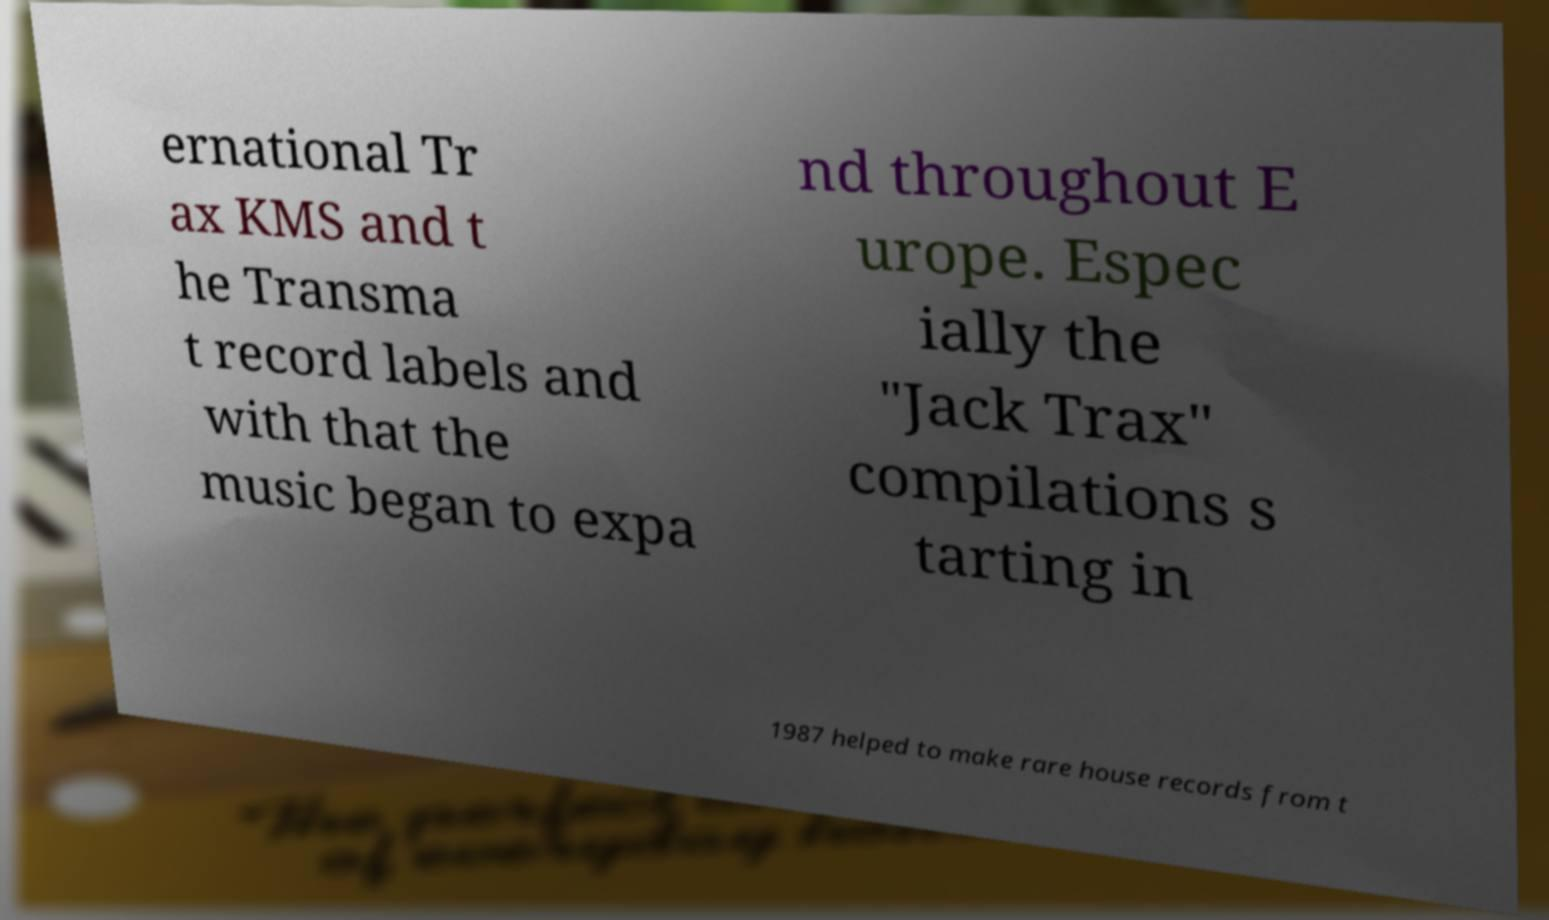Please identify and transcribe the text found in this image. ernational Tr ax KMS and t he Transma t record labels and with that the music began to expa nd throughout E urope. Espec ially the "Jack Trax" compilations s tarting in 1987 helped to make rare house records from t 